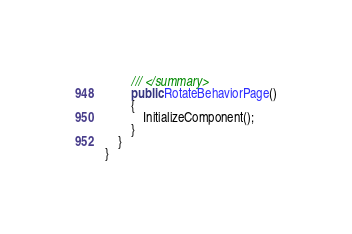<code> <loc_0><loc_0><loc_500><loc_500><_C#_>        /// </summary>
        public RotateBehaviorPage()
        {
            InitializeComponent();
        }
    }
}
</code> 